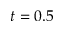<formula> <loc_0><loc_0><loc_500><loc_500>t = 0 . 5</formula> 